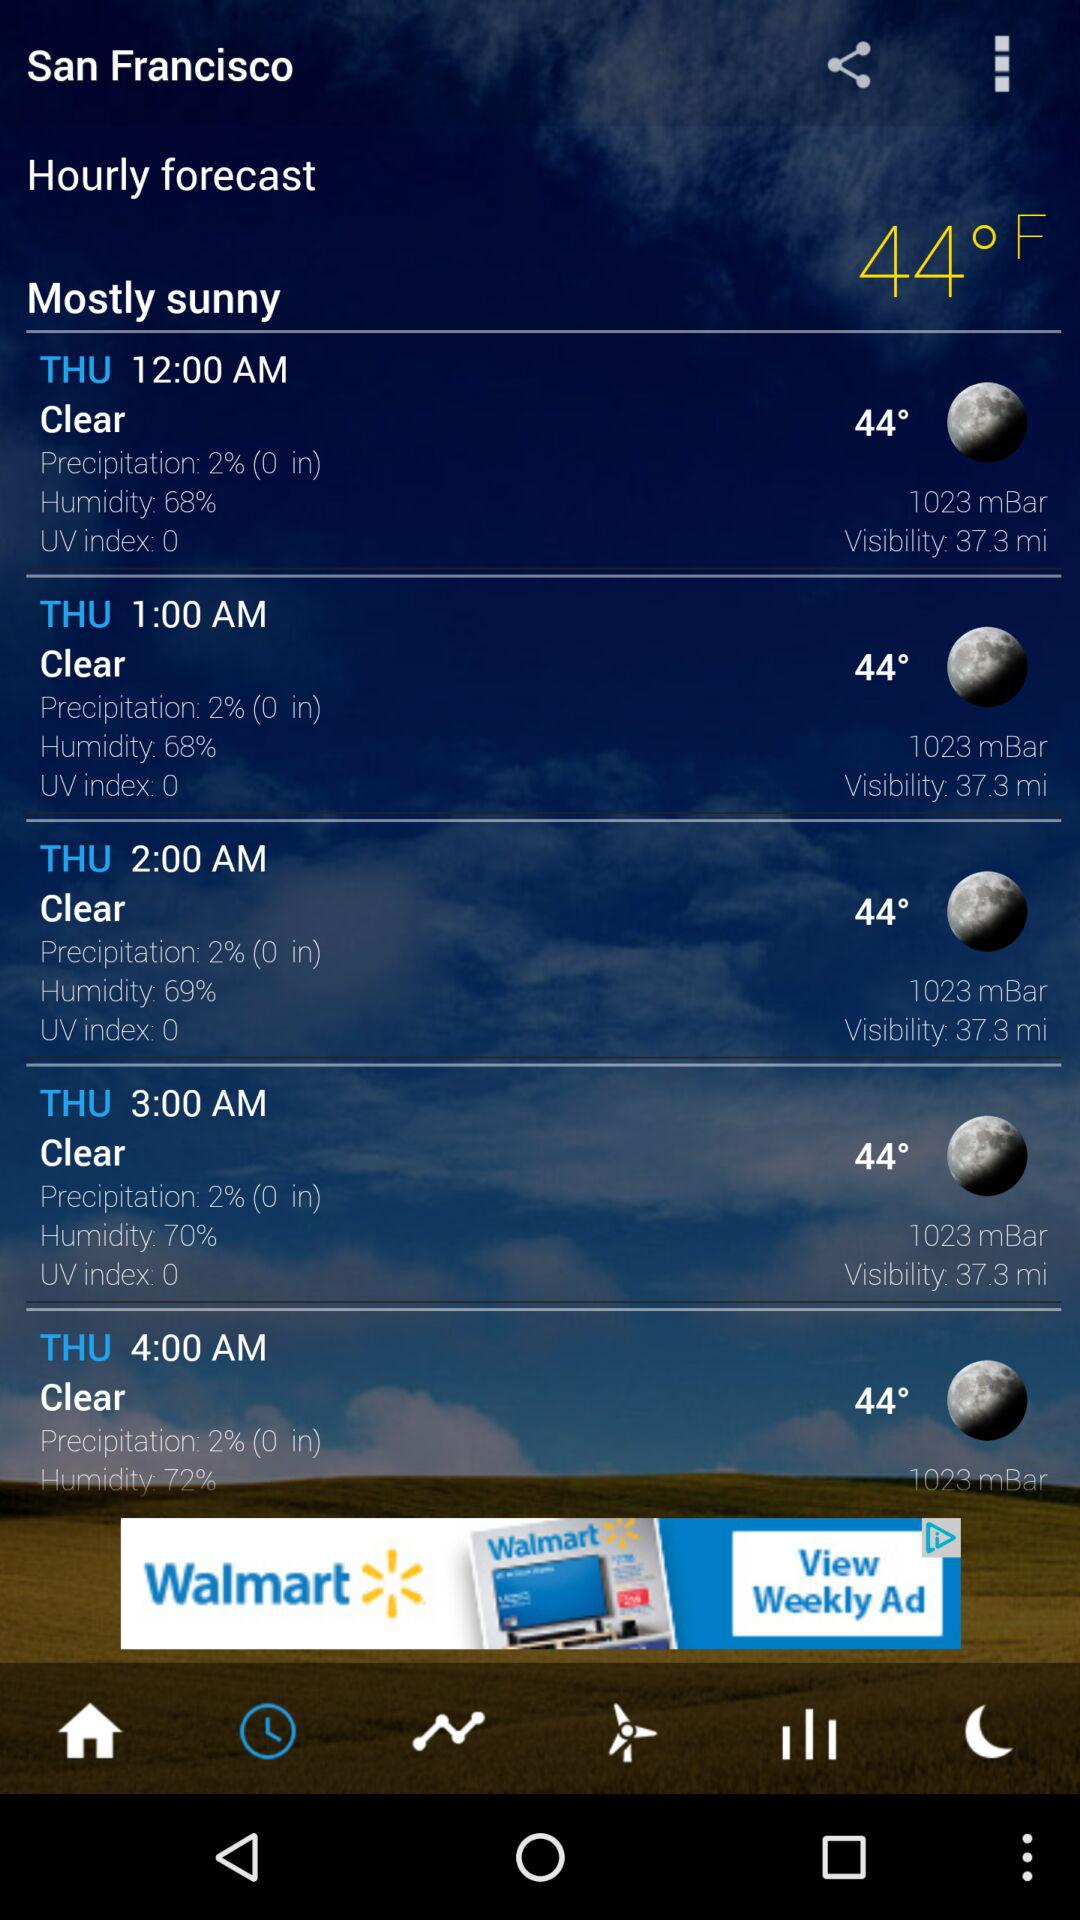What is the visibility at 1.00 AM? The visibility is 37.3 miles. 